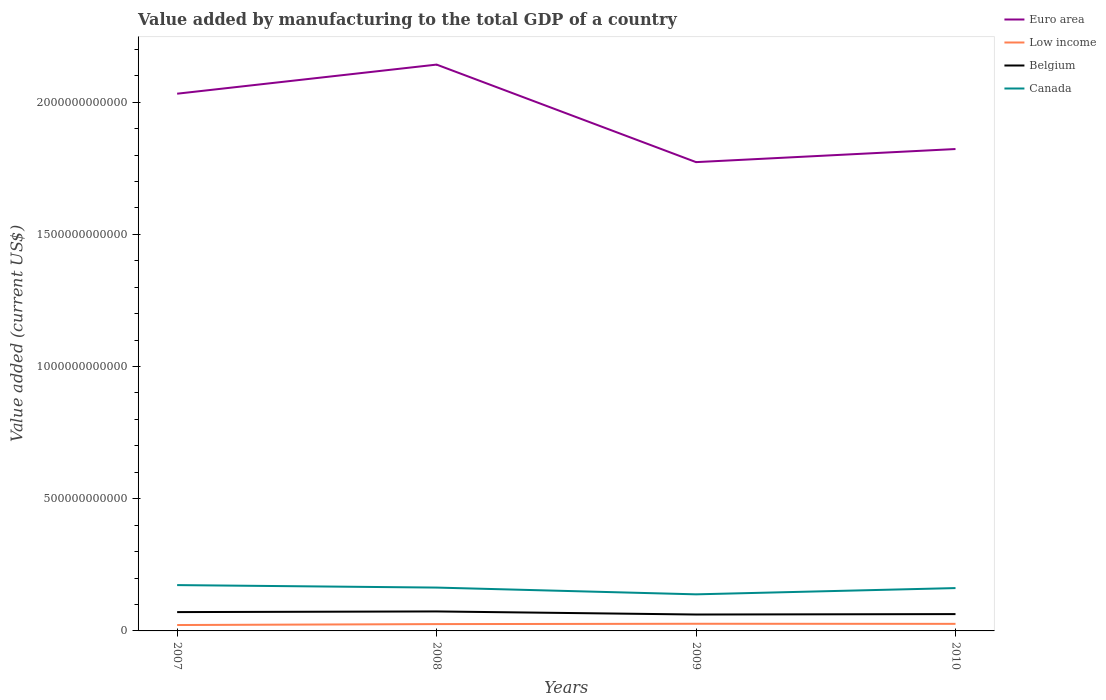How many different coloured lines are there?
Provide a succinct answer. 4. Across all years, what is the maximum value added by manufacturing to the total GDP in Belgium?
Your answer should be very brief. 6.20e+1. In which year was the value added by manufacturing to the total GDP in Low income maximum?
Keep it short and to the point. 2007. What is the total value added by manufacturing to the total GDP in Canada in the graph?
Keep it short and to the point. 1.87e+09. What is the difference between the highest and the second highest value added by manufacturing to the total GDP in Canada?
Your answer should be very brief. 3.50e+1. What is the difference between the highest and the lowest value added by manufacturing to the total GDP in Euro area?
Your answer should be compact. 2. Is the value added by manufacturing to the total GDP in Low income strictly greater than the value added by manufacturing to the total GDP in Euro area over the years?
Offer a very short reply. Yes. How many lines are there?
Ensure brevity in your answer.  4. How many years are there in the graph?
Your answer should be very brief. 4. What is the difference between two consecutive major ticks on the Y-axis?
Keep it short and to the point. 5.00e+11. Are the values on the major ticks of Y-axis written in scientific E-notation?
Your response must be concise. No. Does the graph contain any zero values?
Your response must be concise. No. Does the graph contain grids?
Make the answer very short. No. What is the title of the graph?
Your answer should be very brief. Value added by manufacturing to the total GDP of a country. Does "St. Lucia" appear as one of the legend labels in the graph?
Your answer should be compact. No. What is the label or title of the X-axis?
Make the answer very short. Years. What is the label or title of the Y-axis?
Offer a terse response. Value added (current US$). What is the Value added (current US$) of Euro area in 2007?
Offer a terse response. 2.03e+12. What is the Value added (current US$) of Low income in 2007?
Your response must be concise. 2.23e+1. What is the Value added (current US$) of Belgium in 2007?
Offer a very short reply. 7.12e+1. What is the Value added (current US$) of Canada in 2007?
Ensure brevity in your answer.  1.73e+11. What is the Value added (current US$) of Euro area in 2008?
Provide a succinct answer. 2.14e+12. What is the Value added (current US$) of Low income in 2008?
Ensure brevity in your answer.  2.58e+1. What is the Value added (current US$) in Belgium in 2008?
Your response must be concise. 7.37e+1. What is the Value added (current US$) of Canada in 2008?
Offer a terse response. 1.64e+11. What is the Value added (current US$) of Euro area in 2009?
Provide a succinct answer. 1.77e+12. What is the Value added (current US$) in Low income in 2009?
Give a very brief answer. 2.70e+1. What is the Value added (current US$) of Belgium in 2009?
Provide a short and direct response. 6.20e+1. What is the Value added (current US$) in Canada in 2009?
Your response must be concise. 1.38e+11. What is the Value added (current US$) in Euro area in 2010?
Your response must be concise. 1.82e+12. What is the Value added (current US$) in Low income in 2010?
Your response must be concise. 2.67e+1. What is the Value added (current US$) in Belgium in 2010?
Keep it short and to the point. 6.37e+1. What is the Value added (current US$) in Canada in 2010?
Provide a short and direct response. 1.62e+11. Across all years, what is the maximum Value added (current US$) of Euro area?
Offer a terse response. 2.14e+12. Across all years, what is the maximum Value added (current US$) in Low income?
Offer a very short reply. 2.70e+1. Across all years, what is the maximum Value added (current US$) of Belgium?
Your response must be concise. 7.37e+1. Across all years, what is the maximum Value added (current US$) in Canada?
Keep it short and to the point. 1.73e+11. Across all years, what is the minimum Value added (current US$) in Euro area?
Provide a succinct answer. 1.77e+12. Across all years, what is the minimum Value added (current US$) of Low income?
Your answer should be compact. 2.23e+1. Across all years, what is the minimum Value added (current US$) in Belgium?
Offer a terse response. 6.20e+1. Across all years, what is the minimum Value added (current US$) in Canada?
Your response must be concise. 1.38e+11. What is the total Value added (current US$) in Euro area in the graph?
Make the answer very short. 7.77e+12. What is the total Value added (current US$) of Low income in the graph?
Make the answer very short. 1.02e+11. What is the total Value added (current US$) in Belgium in the graph?
Provide a succinct answer. 2.71e+11. What is the total Value added (current US$) in Canada in the graph?
Provide a succinct answer. 6.38e+11. What is the difference between the Value added (current US$) of Euro area in 2007 and that in 2008?
Provide a short and direct response. -1.10e+11. What is the difference between the Value added (current US$) of Low income in 2007 and that in 2008?
Make the answer very short. -3.51e+09. What is the difference between the Value added (current US$) in Belgium in 2007 and that in 2008?
Keep it short and to the point. -2.45e+09. What is the difference between the Value added (current US$) of Canada in 2007 and that in 2008?
Make the answer very short. 9.42e+09. What is the difference between the Value added (current US$) in Euro area in 2007 and that in 2009?
Keep it short and to the point. 2.59e+11. What is the difference between the Value added (current US$) of Low income in 2007 and that in 2009?
Ensure brevity in your answer.  -4.75e+09. What is the difference between the Value added (current US$) in Belgium in 2007 and that in 2009?
Offer a terse response. 9.20e+09. What is the difference between the Value added (current US$) of Canada in 2007 and that in 2009?
Offer a terse response. 3.50e+1. What is the difference between the Value added (current US$) of Euro area in 2007 and that in 2010?
Provide a short and direct response. 2.09e+11. What is the difference between the Value added (current US$) of Low income in 2007 and that in 2010?
Keep it short and to the point. -4.44e+09. What is the difference between the Value added (current US$) of Belgium in 2007 and that in 2010?
Offer a terse response. 7.56e+09. What is the difference between the Value added (current US$) of Canada in 2007 and that in 2010?
Provide a succinct answer. 1.13e+1. What is the difference between the Value added (current US$) in Euro area in 2008 and that in 2009?
Ensure brevity in your answer.  3.69e+11. What is the difference between the Value added (current US$) of Low income in 2008 and that in 2009?
Provide a short and direct response. -1.23e+09. What is the difference between the Value added (current US$) of Belgium in 2008 and that in 2009?
Ensure brevity in your answer.  1.16e+1. What is the difference between the Value added (current US$) of Canada in 2008 and that in 2009?
Provide a succinct answer. 2.56e+1. What is the difference between the Value added (current US$) in Euro area in 2008 and that in 2010?
Provide a short and direct response. 3.19e+11. What is the difference between the Value added (current US$) in Low income in 2008 and that in 2010?
Provide a succinct answer. -9.26e+08. What is the difference between the Value added (current US$) of Belgium in 2008 and that in 2010?
Offer a very short reply. 1.00e+1. What is the difference between the Value added (current US$) in Canada in 2008 and that in 2010?
Your answer should be compact. 1.87e+09. What is the difference between the Value added (current US$) in Euro area in 2009 and that in 2010?
Give a very brief answer. -4.95e+1. What is the difference between the Value added (current US$) of Low income in 2009 and that in 2010?
Your answer should be very brief. 3.08e+08. What is the difference between the Value added (current US$) in Belgium in 2009 and that in 2010?
Your answer should be compact. -1.64e+09. What is the difference between the Value added (current US$) in Canada in 2009 and that in 2010?
Offer a terse response. -2.37e+1. What is the difference between the Value added (current US$) in Euro area in 2007 and the Value added (current US$) in Low income in 2008?
Your answer should be very brief. 2.01e+12. What is the difference between the Value added (current US$) in Euro area in 2007 and the Value added (current US$) in Belgium in 2008?
Your response must be concise. 1.96e+12. What is the difference between the Value added (current US$) of Euro area in 2007 and the Value added (current US$) of Canada in 2008?
Keep it short and to the point. 1.87e+12. What is the difference between the Value added (current US$) of Low income in 2007 and the Value added (current US$) of Belgium in 2008?
Your answer should be very brief. -5.14e+1. What is the difference between the Value added (current US$) in Low income in 2007 and the Value added (current US$) in Canada in 2008?
Ensure brevity in your answer.  -1.42e+11. What is the difference between the Value added (current US$) of Belgium in 2007 and the Value added (current US$) of Canada in 2008?
Offer a very short reply. -9.27e+1. What is the difference between the Value added (current US$) in Euro area in 2007 and the Value added (current US$) in Low income in 2009?
Offer a terse response. 2.01e+12. What is the difference between the Value added (current US$) of Euro area in 2007 and the Value added (current US$) of Belgium in 2009?
Keep it short and to the point. 1.97e+12. What is the difference between the Value added (current US$) in Euro area in 2007 and the Value added (current US$) in Canada in 2009?
Your answer should be compact. 1.89e+12. What is the difference between the Value added (current US$) of Low income in 2007 and the Value added (current US$) of Belgium in 2009?
Your answer should be compact. -3.97e+1. What is the difference between the Value added (current US$) in Low income in 2007 and the Value added (current US$) in Canada in 2009?
Provide a succinct answer. -1.16e+11. What is the difference between the Value added (current US$) of Belgium in 2007 and the Value added (current US$) of Canada in 2009?
Your response must be concise. -6.71e+1. What is the difference between the Value added (current US$) in Euro area in 2007 and the Value added (current US$) in Low income in 2010?
Your answer should be compact. 2.01e+12. What is the difference between the Value added (current US$) of Euro area in 2007 and the Value added (current US$) of Belgium in 2010?
Provide a short and direct response. 1.97e+12. What is the difference between the Value added (current US$) of Euro area in 2007 and the Value added (current US$) of Canada in 2010?
Ensure brevity in your answer.  1.87e+12. What is the difference between the Value added (current US$) of Low income in 2007 and the Value added (current US$) of Belgium in 2010?
Ensure brevity in your answer.  -4.14e+1. What is the difference between the Value added (current US$) in Low income in 2007 and the Value added (current US$) in Canada in 2010?
Provide a succinct answer. -1.40e+11. What is the difference between the Value added (current US$) of Belgium in 2007 and the Value added (current US$) of Canada in 2010?
Make the answer very short. -9.08e+1. What is the difference between the Value added (current US$) in Euro area in 2008 and the Value added (current US$) in Low income in 2009?
Provide a short and direct response. 2.12e+12. What is the difference between the Value added (current US$) in Euro area in 2008 and the Value added (current US$) in Belgium in 2009?
Provide a succinct answer. 2.08e+12. What is the difference between the Value added (current US$) in Euro area in 2008 and the Value added (current US$) in Canada in 2009?
Provide a short and direct response. 2.00e+12. What is the difference between the Value added (current US$) of Low income in 2008 and the Value added (current US$) of Belgium in 2009?
Make the answer very short. -3.62e+1. What is the difference between the Value added (current US$) in Low income in 2008 and the Value added (current US$) in Canada in 2009?
Ensure brevity in your answer.  -1.13e+11. What is the difference between the Value added (current US$) in Belgium in 2008 and the Value added (current US$) in Canada in 2009?
Give a very brief answer. -6.47e+1. What is the difference between the Value added (current US$) in Euro area in 2008 and the Value added (current US$) in Low income in 2010?
Offer a very short reply. 2.12e+12. What is the difference between the Value added (current US$) in Euro area in 2008 and the Value added (current US$) in Belgium in 2010?
Your answer should be very brief. 2.08e+12. What is the difference between the Value added (current US$) of Euro area in 2008 and the Value added (current US$) of Canada in 2010?
Your answer should be compact. 1.98e+12. What is the difference between the Value added (current US$) in Low income in 2008 and the Value added (current US$) in Belgium in 2010?
Offer a very short reply. -3.79e+1. What is the difference between the Value added (current US$) in Low income in 2008 and the Value added (current US$) in Canada in 2010?
Your answer should be very brief. -1.36e+11. What is the difference between the Value added (current US$) in Belgium in 2008 and the Value added (current US$) in Canada in 2010?
Your answer should be compact. -8.84e+1. What is the difference between the Value added (current US$) in Euro area in 2009 and the Value added (current US$) in Low income in 2010?
Keep it short and to the point. 1.75e+12. What is the difference between the Value added (current US$) of Euro area in 2009 and the Value added (current US$) of Belgium in 2010?
Offer a terse response. 1.71e+12. What is the difference between the Value added (current US$) in Euro area in 2009 and the Value added (current US$) in Canada in 2010?
Your response must be concise. 1.61e+12. What is the difference between the Value added (current US$) in Low income in 2009 and the Value added (current US$) in Belgium in 2010?
Offer a terse response. -3.66e+1. What is the difference between the Value added (current US$) of Low income in 2009 and the Value added (current US$) of Canada in 2010?
Make the answer very short. -1.35e+11. What is the difference between the Value added (current US$) in Belgium in 2009 and the Value added (current US$) in Canada in 2010?
Offer a terse response. -1.00e+11. What is the average Value added (current US$) in Euro area per year?
Your answer should be compact. 1.94e+12. What is the average Value added (current US$) of Low income per year?
Ensure brevity in your answer.  2.55e+1. What is the average Value added (current US$) in Belgium per year?
Keep it short and to the point. 6.77e+1. What is the average Value added (current US$) of Canada per year?
Offer a very short reply. 1.59e+11. In the year 2007, what is the difference between the Value added (current US$) in Euro area and Value added (current US$) in Low income?
Your answer should be compact. 2.01e+12. In the year 2007, what is the difference between the Value added (current US$) in Euro area and Value added (current US$) in Belgium?
Provide a short and direct response. 1.96e+12. In the year 2007, what is the difference between the Value added (current US$) in Euro area and Value added (current US$) in Canada?
Offer a terse response. 1.86e+12. In the year 2007, what is the difference between the Value added (current US$) in Low income and Value added (current US$) in Belgium?
Your response must be concise. -4.89e+1. In the year 2007, what is the difference between the Value added (current US$) in Low income and Value added (current US$) in Canada?
Your answer should be very brief. -1.51e+11. In the year 2007, what is the difference between the Value added (current US$) in Belgium and Value added (current US$) in Canada?
Your response must be concise. -1.02e+11. In the year 2008, what is the difference between the Value added (current US$) in Euro area and Value added (current US$) in Low income?
Your answer should be very brief. 2.12e+12. In the year 2008, what is the difference between the Value added (current US$) in Euro area and Value added (current US$) in Belgium?
Give a very brief answer. 2.07e+12. In the year 2008, what is the difference between the Value added (current US$) of Euro area and Value added (current US$) of Canada?
Your answer should be very brief. 1.98e+12. In the year 2008, what is the difference between the Value added (current US$) of Low income and Value added (current US$) of Belgium?
Your answer should be compact. -4.79e+1. In the year 2008, what is the difference between the Value added (current US$) in Low income and Value added (current US$) in Canada?
Keep it short and to the point. -1.38e+11. In the year 2008, what is the difference between the Value added (current US$) of Belgium and Value added (current US$) of Canada?
Offer a very short reply. -9.03e+1. In the year 2009, what is the difference between the Value added (current US$) of Euro area and Value added (current US$) of Low income?
Provide a succinct answer. 1.75e+12. In the year 2009, what is the difference between the Value added (current US$) in Euro area and Value added (current US$) in Belgium?
Make the answer very short. 1.71e+12. In the year 2009, what is the difference between the Value added (current US$) of Euro area and Value added (current US$) of Canada?
Provide a succinct answer. 1.63e+12. In the year 2009, what is the difference between the Value added (current US$) of Low income and Value added (current US$) of Belgium?
Offer a very short reply. -3.50e+1. In the year 2009, what is the difference between the Value added (current US$) in Low income and Value added (current US$) in Canada?
Keep it short and to the point. -1.11e+11. In the year 2009, what is the difference between the Value added (current US$) of Belgium and Value added (current US$) of Canada?
Ensure brevity in your answer.  -7.63e+1. In the year 2010, what is the difference between the Value added (current US$) in Euro area and Value added (current US$) in Low income?
Keep it short and to the point. 1.80e+12. In the year 2010, what is the difference between the Value added (current US$) in Euro area and Value added (current US$) in Belgium?
Offer a terse response. 1.76e+12. In the year 2010, what is the difference between the Value added (current US$) in Euro area and Value added (current US$) in Canada?
Your answer should be very brief. 1.66e+12. In the year 2010, what is the difference between the Value added (current US$) of Low income and Value added (current US$) of Belgium?
Give a very brief answer. -3.69e+1. In the year 2010, what is the difference between the Value added (current US$) of Low income and Value added (current US$) of Canada?
Offer a very short reply. -1.35e+11. In the year 2010, what is the difference between the Value added (current US$) in Belgium and Value added (current US$) in Canada?
Make the answer very short. -9.84e+1. What is the ratio of the Value added (current US$) in Euro area in 2007 to that in 2008?
Provide a succinct answer. 0.95. What is the ratio of the Value added (current US$) in Low income in 2007 to that in 2008?
Offer a terse response. 0.86. What is the ratio of the Value added (current US$) of Belgium in 2007 to that in 2008?
Keep it short and to the point. 0.97. What is the ratio of the Value added (current US$) of Canada in 2007 to that in 2008?
Your answer should be very brief. 1.06. What is the ratio of the Value added (current US$) of Euro area in 2007 to that in 2009?
Keep it short and to the point. 1.15. What is the ratio of the Value added (current US$) in Low income in 2007 to that in 2009?
Provide a succinct answer. 0.82. What is the ratio of the Value added (current US$) of Belgium in 2007 to that in 2009?
Offer a terse response. 1.15. What is the ratio of the Value added (current US$) of Canada in 2007 to that in 2009?
Offer a very short reply. 1.25. What is the ratio of the Value added (current US$) of Euro area in 2007 to that in 2010?
Keep it short and to the point. 1.11. What is the ratio of the Value added (current US$) in Low income in 2007 to that in 2010?
Provide a short and direct response. 0.83. What is the ratio of the Value added (current US$) of Belgium in 2007 to that in 2010?
Ensure brevity in your answer.  1.12. What is the ratio of the Value added (current US$) of Canada in 2007 to that in 2010?
Provide a short and direct response. 1.07. What is the ratio of the Value added (current US$) in Euro area in 2008 to that in 2009?
Keep it short and to the point. 1.21. What is the ratio of the Value added (current US$) of Low income in 2008 to that in 2009?
Your answer should be very brief. 0.95. What is the ratio of the Value added (current US$) in Belgium in 2008 to that in 2009?
Ensure brevity in your answer.  1.19. What is the ratio of the Value added (current US$) in Canada in 2008 to that in 2009?
Your answer should be very brief. 1.19. What is the ratio of the Value added (current US$) of Euro area in 2008 to that in 2010?
Your response must be concise. 1.18. What is the ratio of the Value added (current US$) of Low income in 2008 to that in 2010?
Keep it short and to the point. 0.97. What is the ratio of the Value added (current US$) in Belgium in 2008 to that in 2010?
Your response must be concise. 1.16. What is the ratio of the Value added (current US$) of Canada in 2008 to that in 2010?
Offer a terse response. 1.01. What is the ratio of the Value added (current US$) of Euro area in 2009 to that in 2010?
Ensure brevity in your answer.  0.97. What is the ratio of the Value added (current US$) of Low income in 2009 to that in 2010?
Your answer should be very brief. 1.01. What is the ratio of the Value added (current US$) of Belgium in 2009 to that in 2010?
Make the answer very short. 0.97. What is the ratio of the Value added (current US$) of Canada in 2009 to that in 2010?
Your answer should be very brief. 0.85. What is the difference between the highest and the second highest Value added (current US$) in Euro area?
Your response must be concise. 1.10e+11. What is the difference between the highest and the second highest Value added (current US$) of Low income?
Give a very brief answer. 3.08e+08. What is the difference between the highest and the second highest Value added (current US$) in Belgium?
Keep it short and to the point. 2.45e+09. What is the difference between the highest and the second highest Value added (current US$) of Canada?
Your answer should be compact. 9.42e+09. What is the difference between the highest and the lowest Value added (current US$) of Euro area?
Your answer should be compact. 3.69e+11. What is the difference between the highest and the lowest Value added (current US$) in Low income?
Your answer should be very brief. 4.75e+09. What is the difference between the highest and the lowest Value added (current US$) of Belgium?
Your response must be concise. 1.16e+1. What is the difference between the highest and the lowest Value added (current US$) in Canada?
Give a very brief answer. 3.50e+1. 